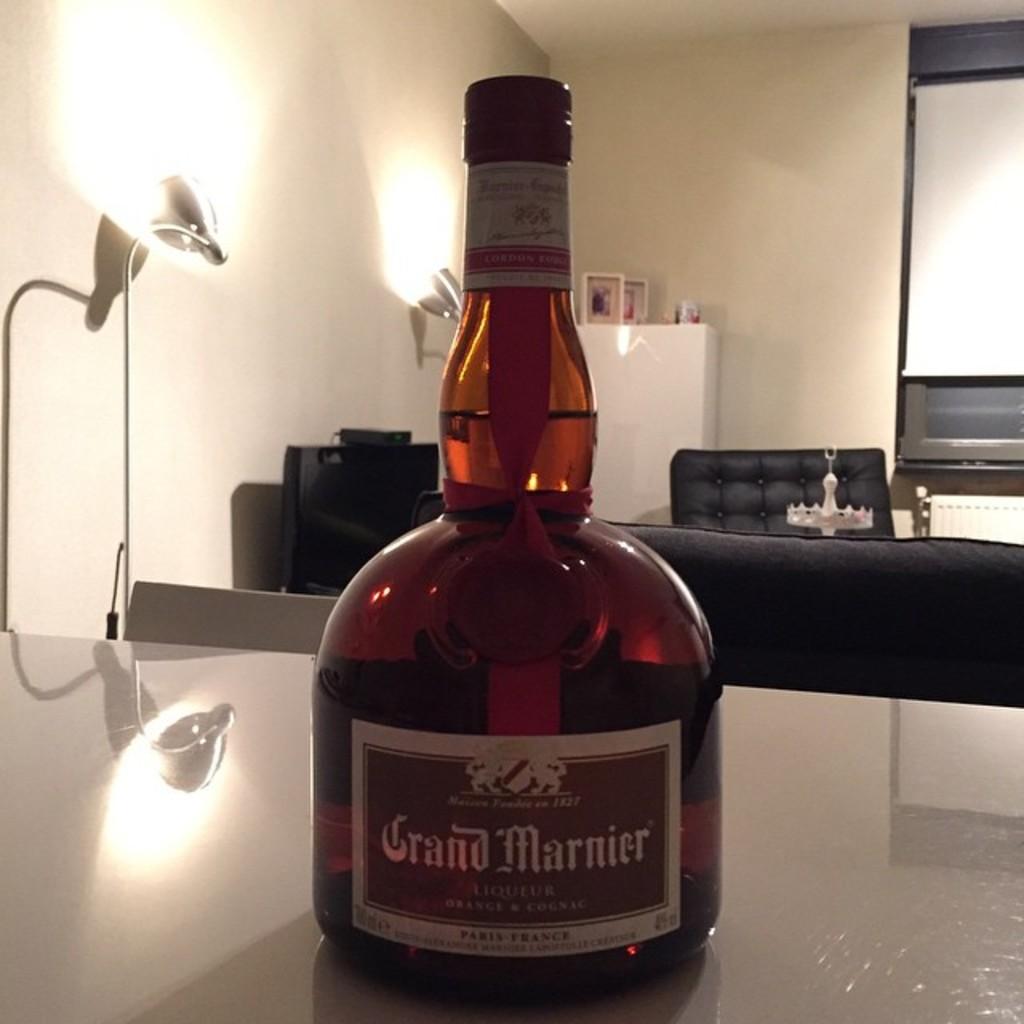What is the name of this orange-flavored liqueur?
Your response must be concise. Grand marnier. What is inside the bottle?
Make the answer very short. Grand marnier. 